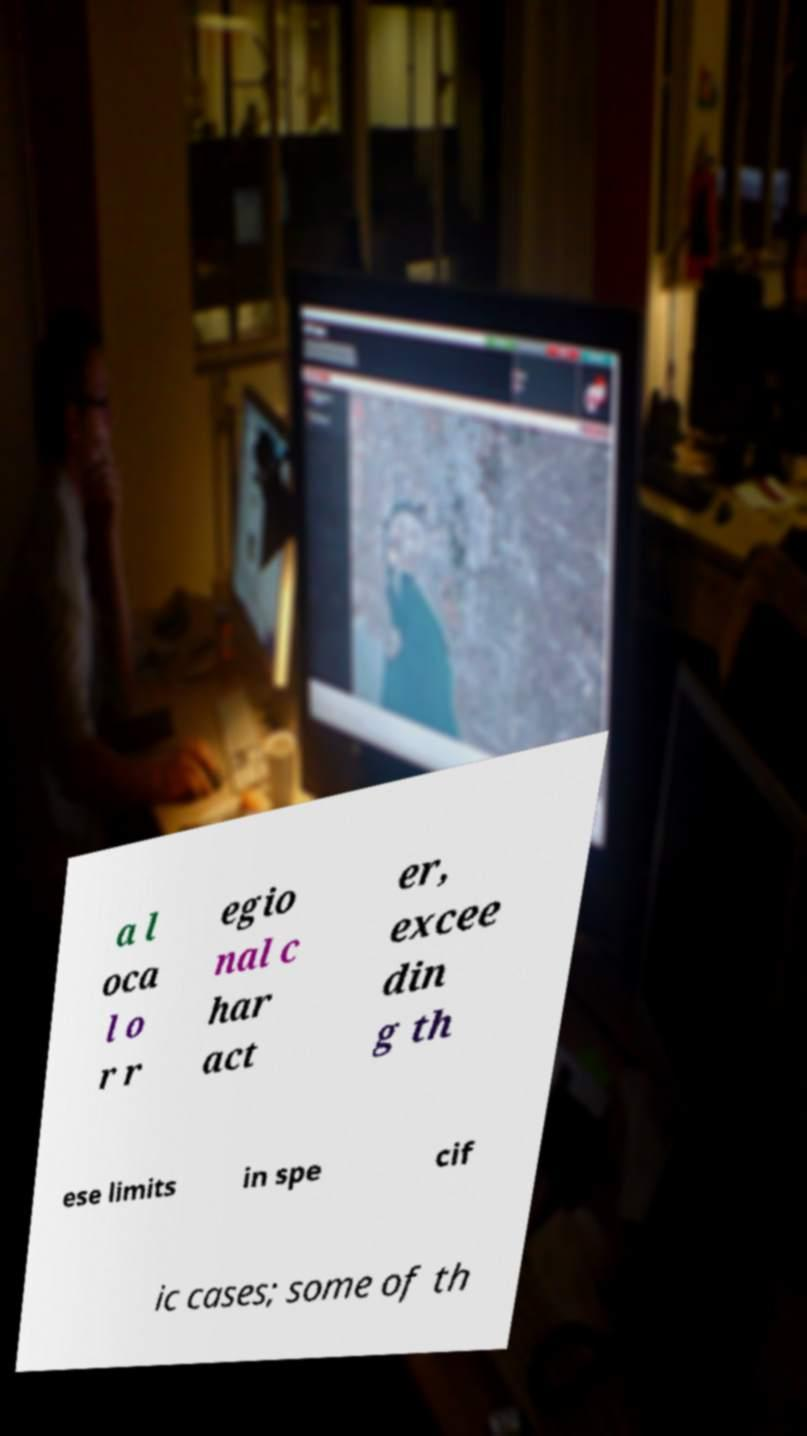Please read and relay the text visible in this image. What does it say? a l oca l o r r egio nal c har act er, excee din g th ese limits in spe cif ic cases; some of th 